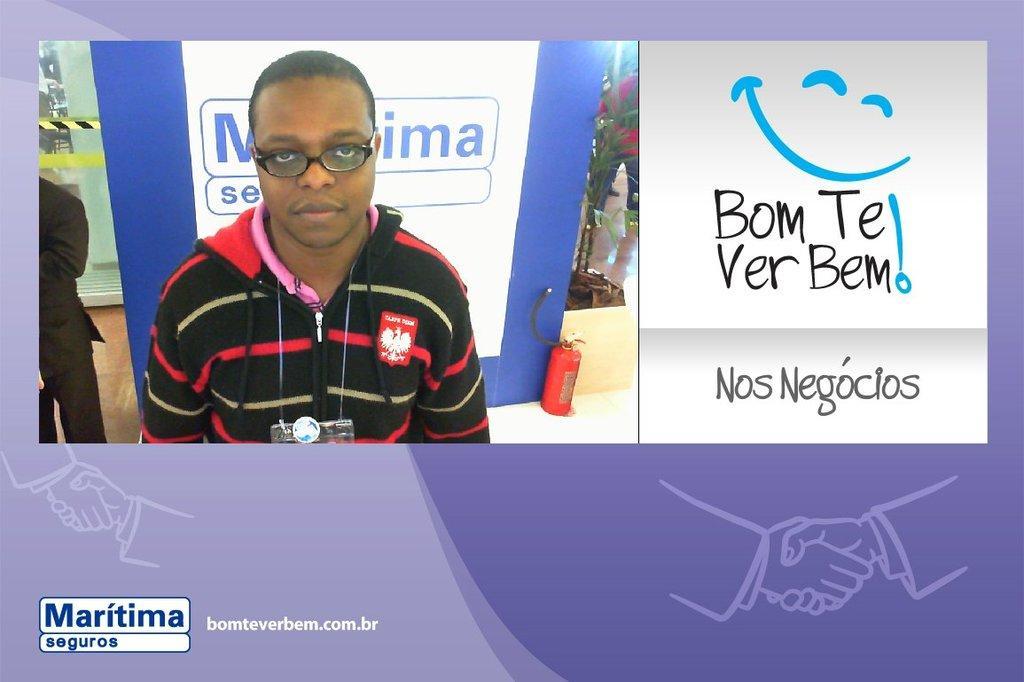In one or two sentences, can you explain what this image depicts? In this picture there is a poster in the center of the image and there is a boy on the left side of the image. 